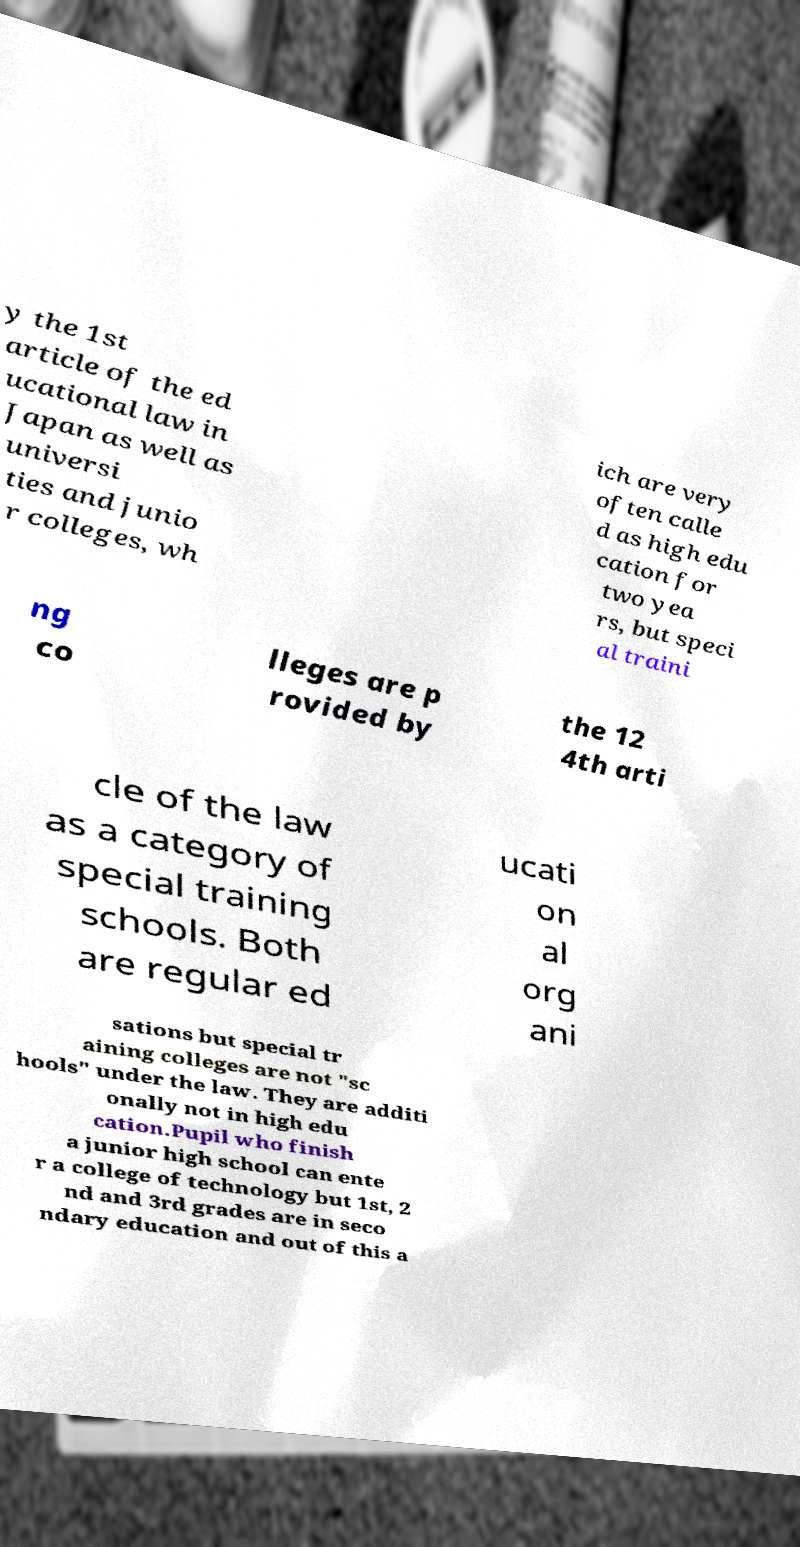Could you assist in decoding the text presented in this image and type it out clearly? y the 1st article of the ed ucational law in Japan as well as universi ties and junio r colleges, wh ich are very often calle d as high edu cation for two yea rs, but speci al traini ng co lleges are p rovided by the 12 4th arti cle of the law as a category of special training schools. Both are regular ed ucati on al org ani sations but special tr aining colleges are not "sc hools" under the law. They are additi onally not in high edu cation.Pupil who finish a junior high school can ente r a college of technology but 1st, 2 nd and 3rd grades are in seco ndary education and out of this a 